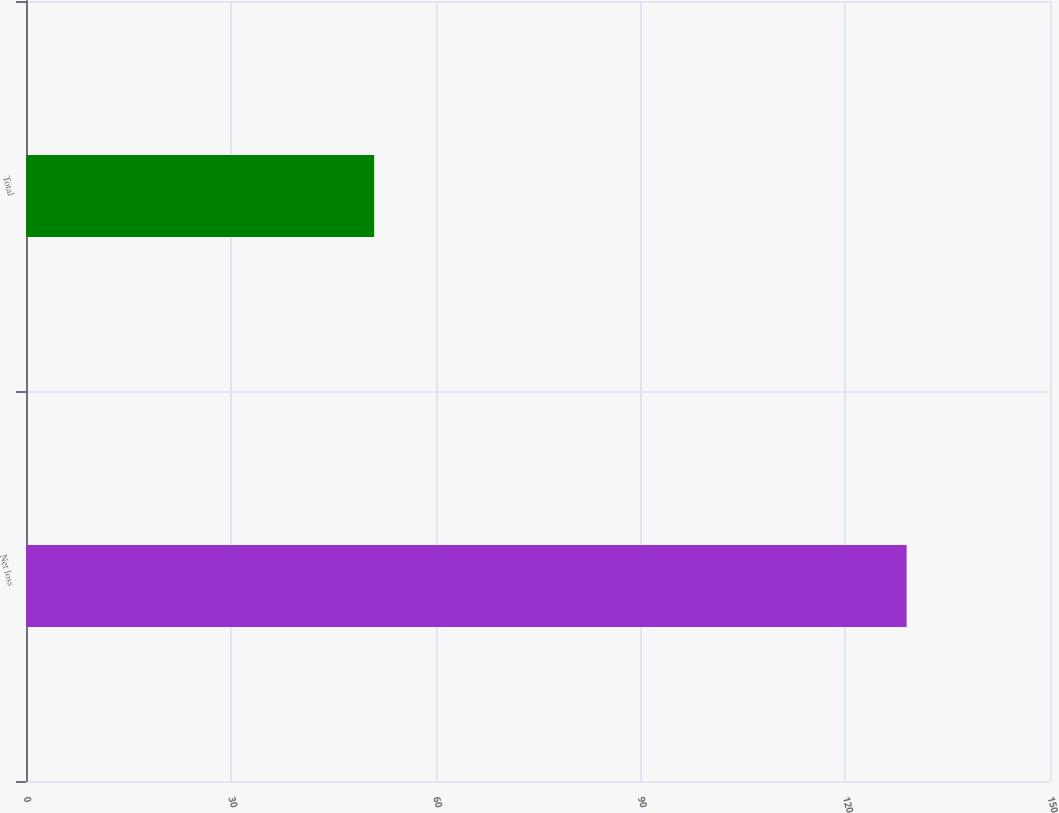Convert chart to OTSL. <chart><loc_0><loc_0><loc_500><loc_500><bar_chart><fcel>Net loss<fcel>Total<nl><fcel>129<fcel>51<nl></chart> 